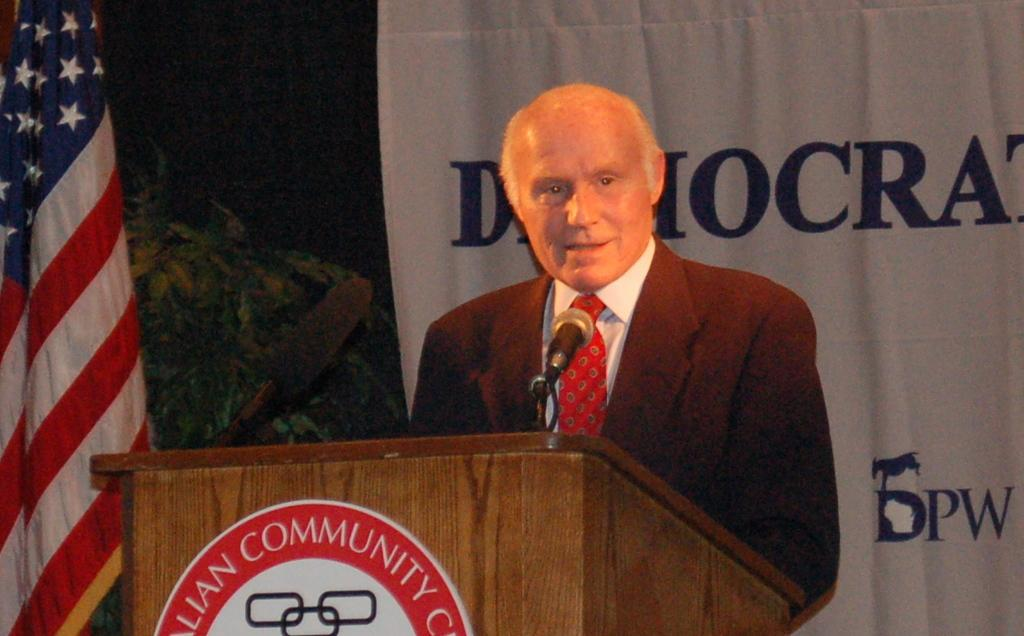Who or what is the main subject in the middle of the image? There is a person in the middle of the image. What is the person standing in front of? The person is standing in front of a podium. What can be found on the podium? A microphone and a board are present on the podium. What can be seen in the background of the image? There is a banner, a plant, and a flag in the background of the image. How does the person in the image express disgust? There is no indication of the person expressing disgust in the image. What type of watch is the person wearing in the image? There is no watch visible on the person in the image. 